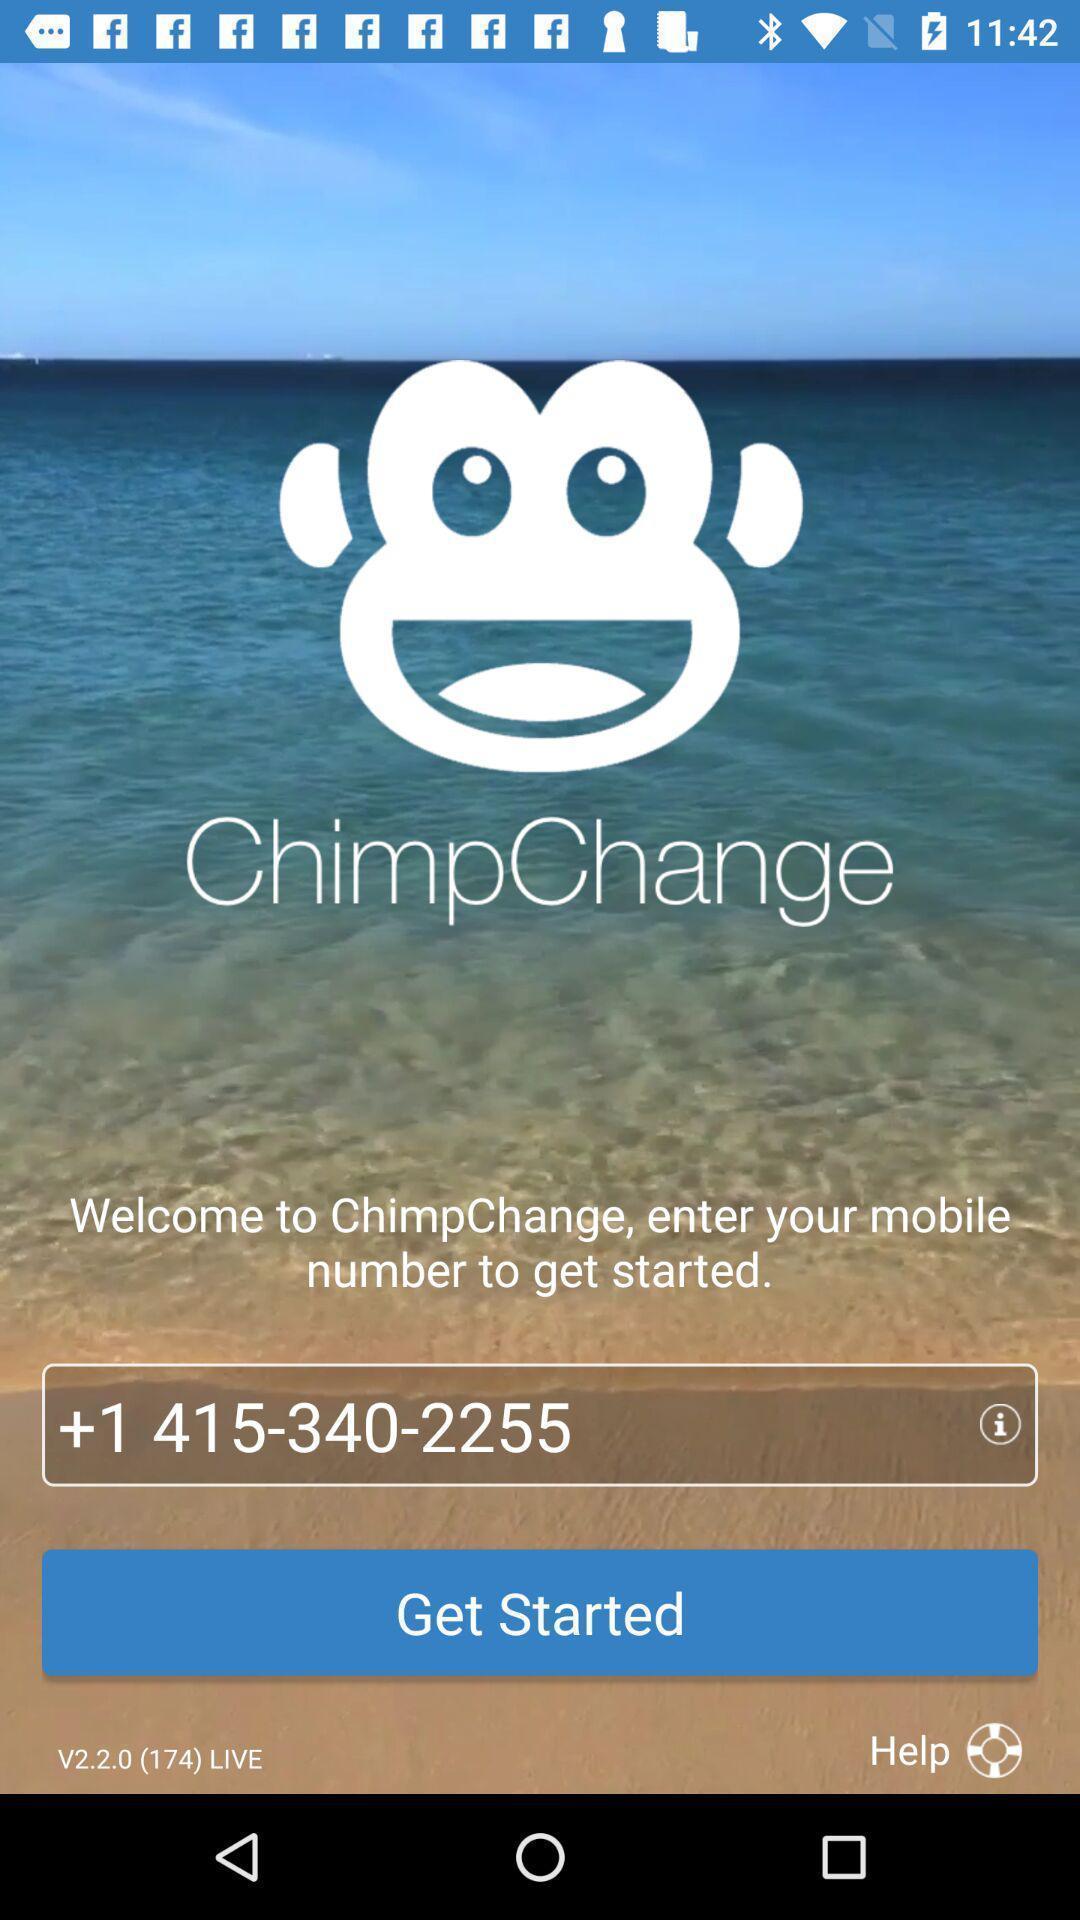Give me a narrative description of this picture. Welcome page of mobile banking app. 